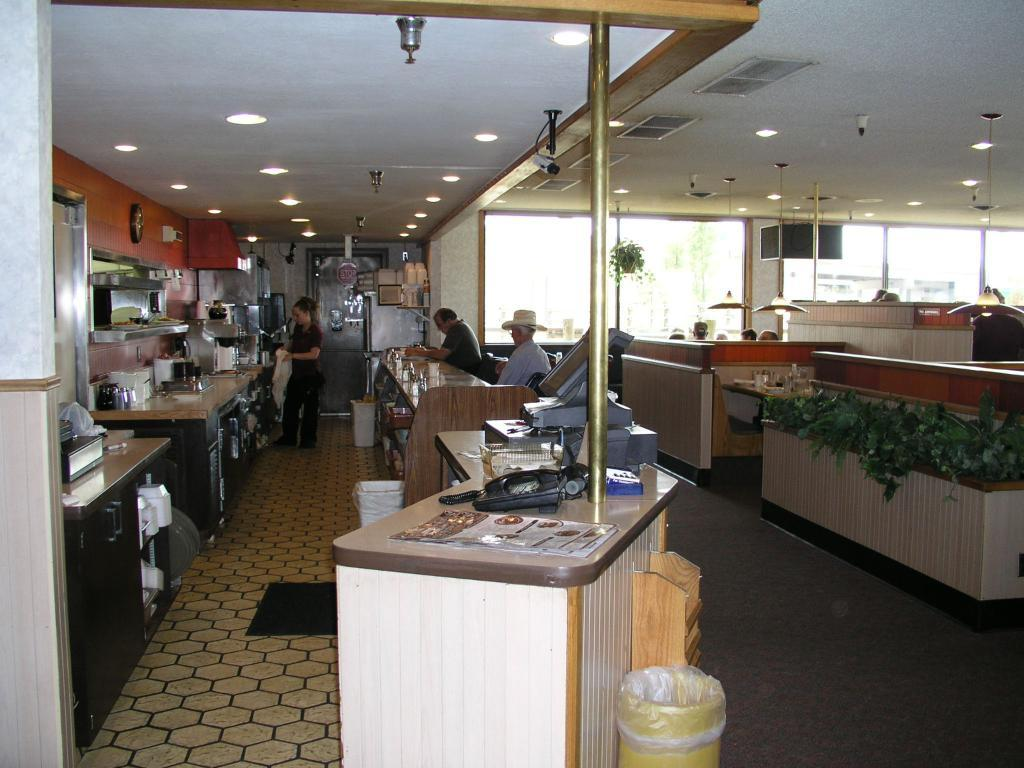What is the woman doing in the image? The woman is standing in the image. How many people are seated in the image? There are two people seated in the image. What objects are on the table in the image? There is a monitor and a telephone on the table in the image. What type of cave is visible in the background of the image? There is no cave present in the image. What story is the woman telling the seated people in the image? There is no indication of a story being told in the image. 